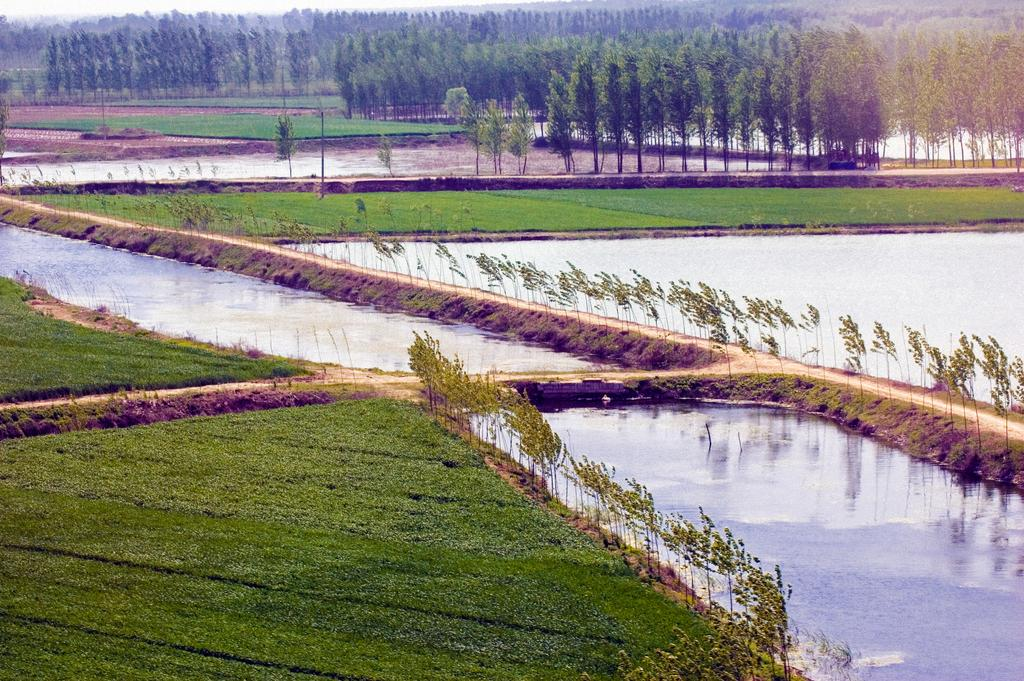What type of vegetation can be seen in the image? There are trees in the image. What bodies of water are present in the image? There are ponds in the image. What type of ground cover is visible in the image? There is grass on the ground in the image. What type of punishment is being administered to the trees in the image? There is no punishment being administered to the trees in the image; they are simply standing in the landscape. What does the image suggest about the belief system of the person who took the photo? The image does not provide any information about the belief system of the person who took the photo. 